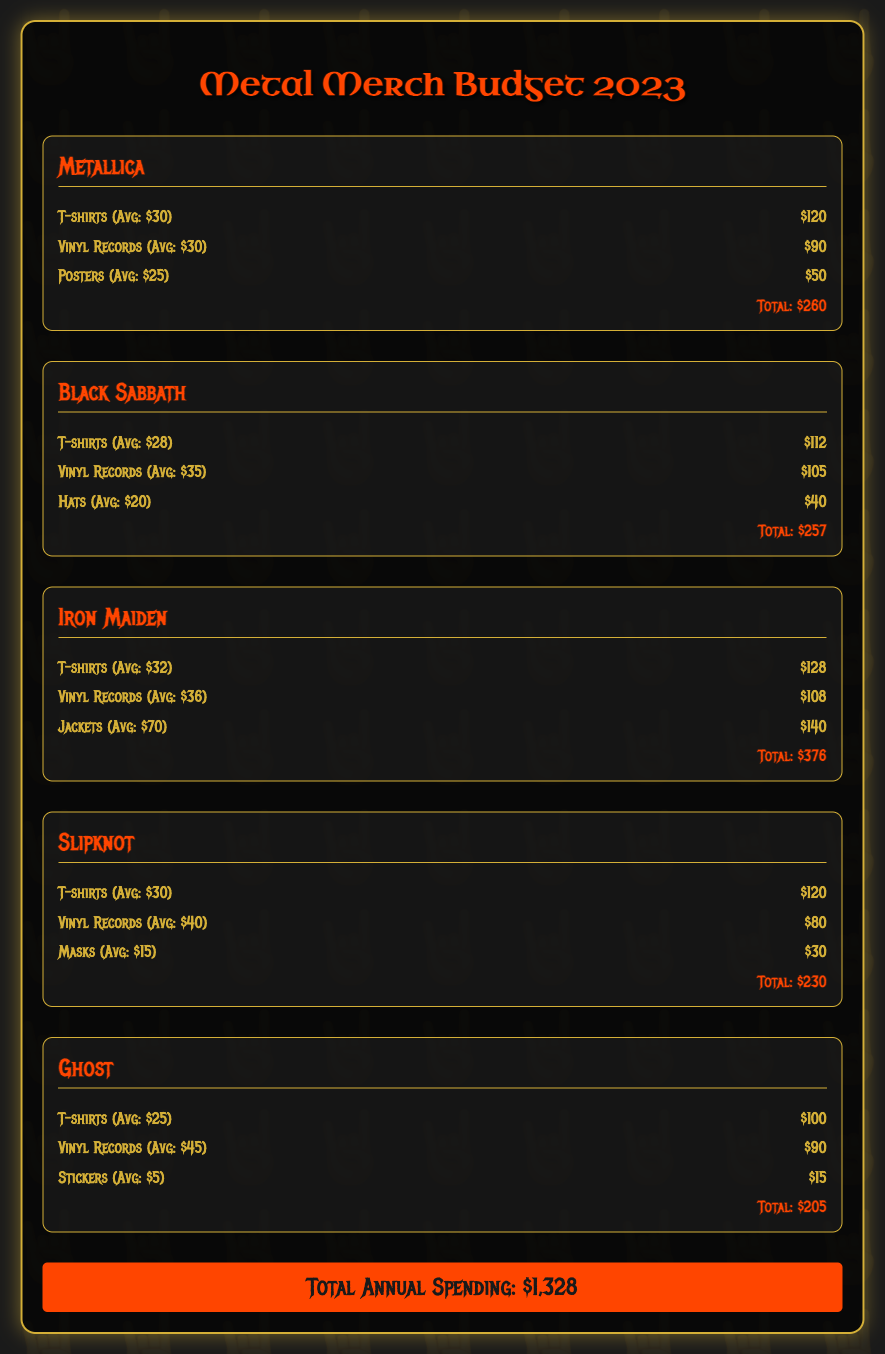what is the total annual spending? The total annual spending is listed at the bottom of the document, which combines all individual totals.
Answer: $1,328 which artist has the highest merchandise spending? The total amounts for each artist shows that Iron Maiden has the highest at $376.
Answer: Iron Maiden how much is spent on vinyl records for Black Sabbath? The document specifies the amount spent on Black Sabbath's vinyl records.
Answer: $105 what is the average cost of a T-shirt for Slipknot? The document provides the average cost of T-shirts for Slipknot as part of their merchandise details.
Answer: $30 which type of item has the lowest annual spending across all artists? By comparing spending on different item types, masks for Slipknot has the lowest total spent at $30.
Answer: Masks how much is allocated for posters for Metallica? The specific expenditure on posters for Metallica is mentioned in the details of their spending.
Answer: $50 what is the average cost of a vinyl record for Ghost? The average cost of vinyl records for Ghost is stated in the merchandise section for this artist.
Answer: $45 which artist has an allocation of $90 for vinyl records? By looking at the vinyl records spending amounts, Ghost has an allocation of $90.
Answer: Ghost 